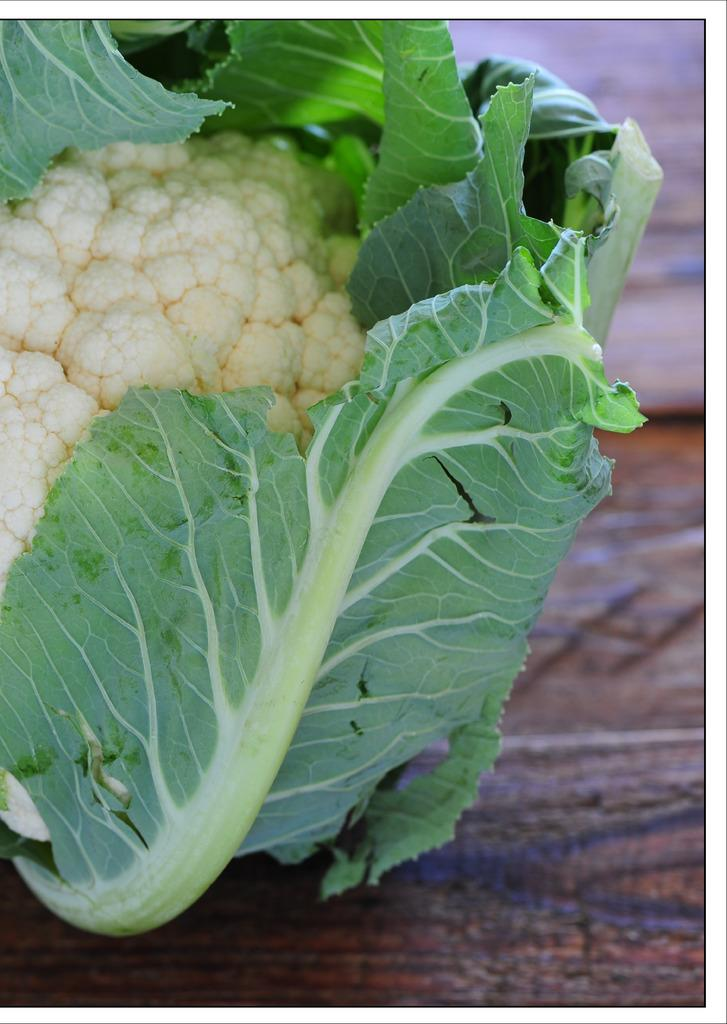What vegetable is the main subject of the image? There is a cauliflower in the image. What part of the cauliflower is visible in the image? The cauliflower leaves are visible in the image. Can you describe the surface on which the cauliflower might be placed? The cauliflower might be placed on a brown table. How would you describe the quality of the image's background? The image is blurred in the background. What type of tooth is visible in the image? There is no tooth visible in the image; it features a cauliflower with leaves. How does the sink appear in the image? There is no sink present in the image. 